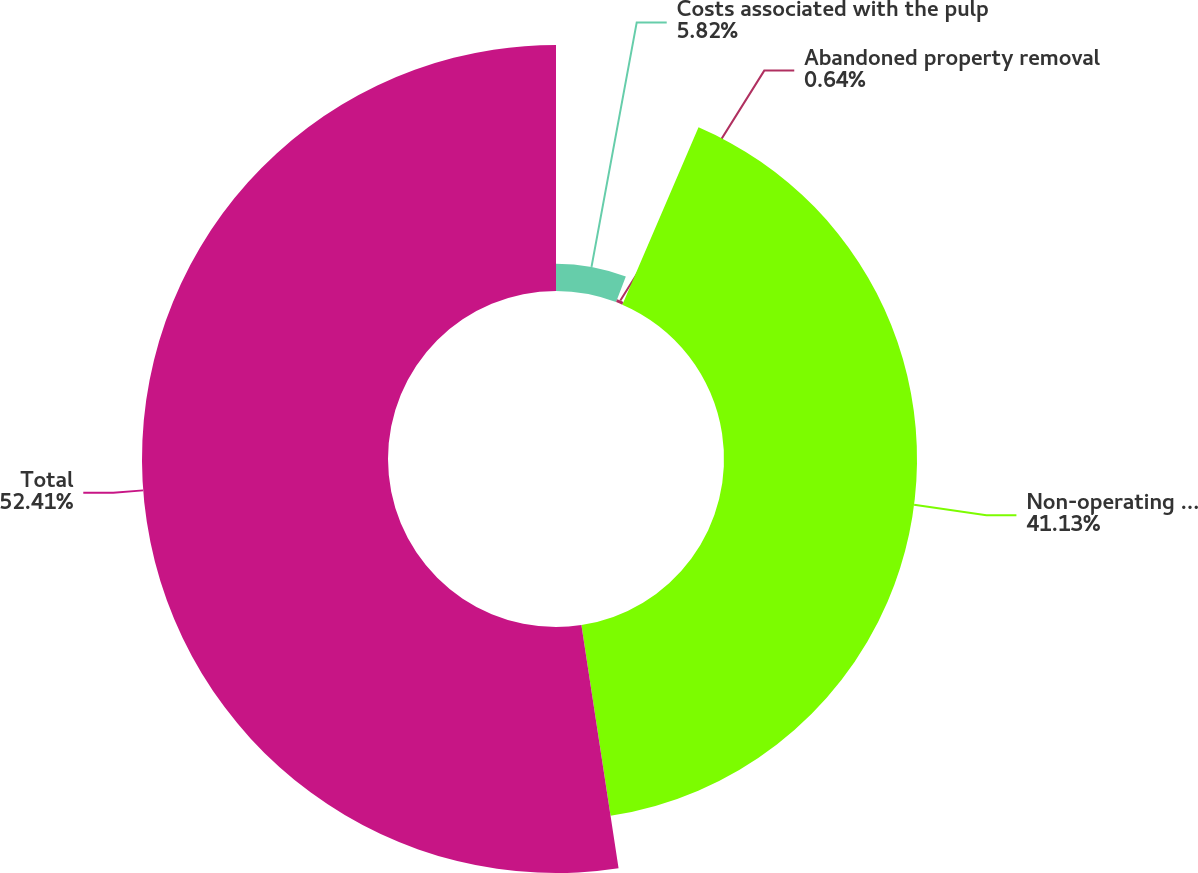Convert chart. <chart><loc_0><loc_0><loc_500><loc_500><pie_chart><fcel>Costs associated with the pulp<fcel>Abandoned property removal<fcel>Non-operating pension expense<fcel>Total<nl><fcel>5.82%<fcel>0.64%<fcel>41.13%<fcel>52.42%<nl></chart> 